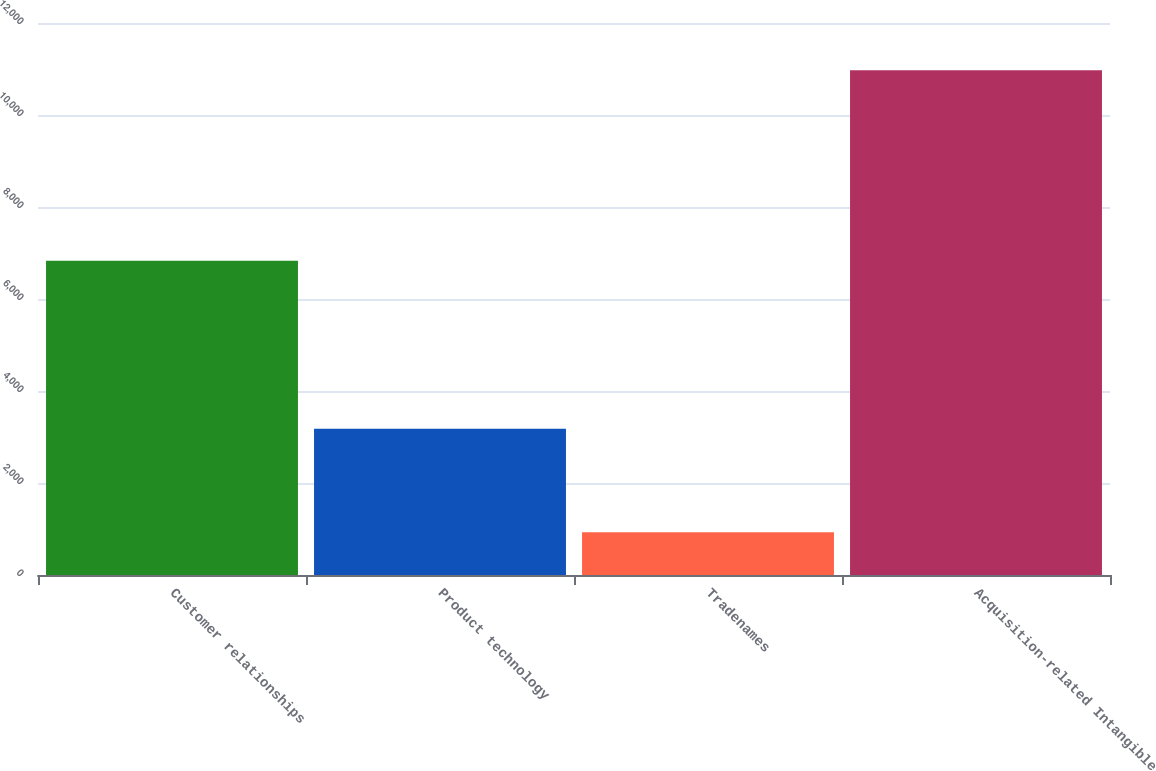Convert chart to OTSL. <chart><loc_0><loc_0><loc_500><loc_500><bar_chart><fcel>Customer relationships<fcel>Product technology<fcel>Tradenames<fcel>Acquisition-related Intangible<nl><fcel>6833<fcel>3178<fcel>929<fcel>10973<nl></chart> 